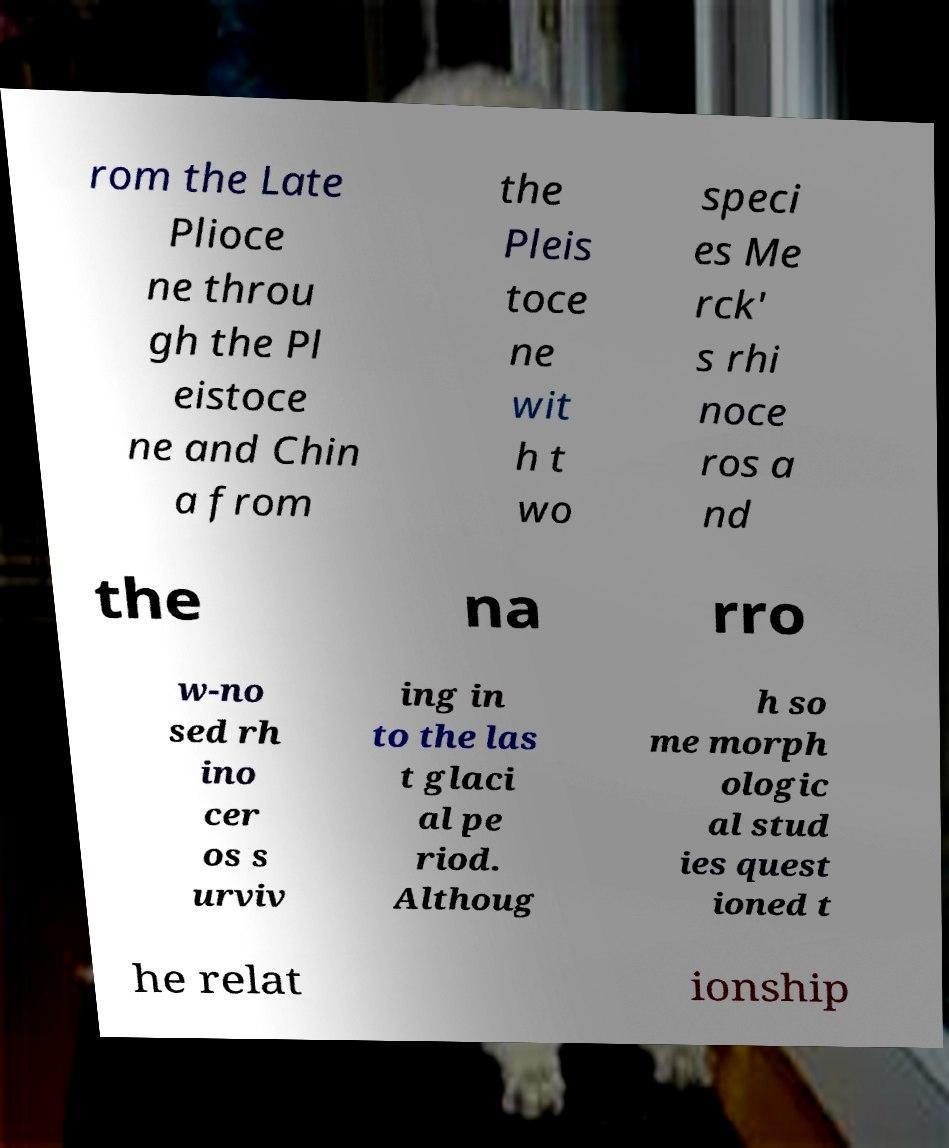There's text embedded in this image that I need extracted. Can you transcribe it verbatim? rom the Late Plioce ne throu gh the Pl eistoce ne and Chin a from the Pleis toce ne wit h t wo speci es Me rck' s rhi noce ros a nd the na rro w-no sed rh ino cer os s urviv ing in to the las t glaci al pe riod. Althoug h so me morph ologic al stud ies quest ioned t he relat ionship 